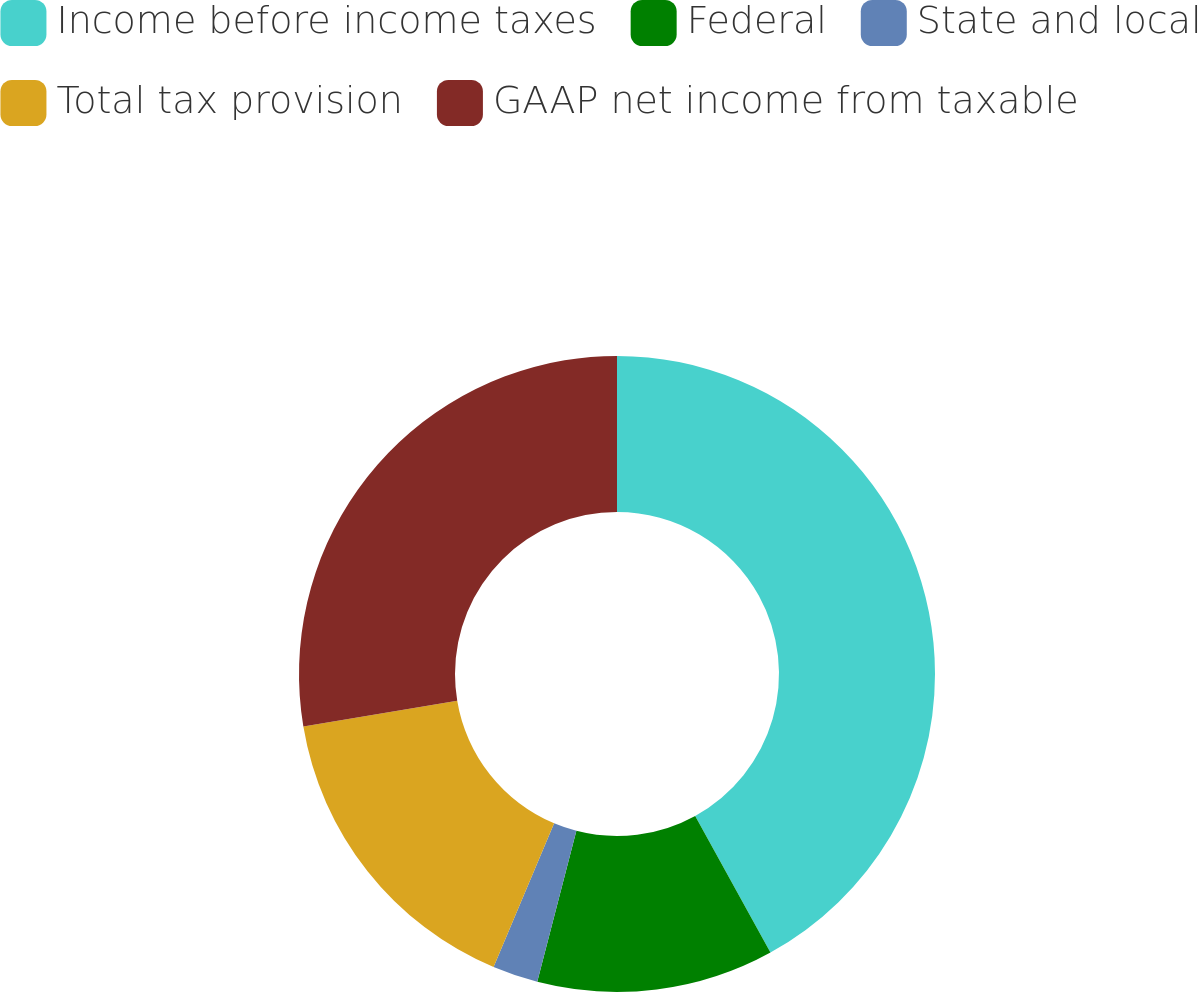Convert chart. <chart><loc_0><loc_0><loc_500><loc_500><pie_chart><fcel>Income before income taxes<fcel>Federal<fcel>State and local<fcel>Total tax provision<fcel>GAAP net income from taxable<nl><fcel>41.99%<fcel>12.05%<fcel>2.31%<fcel>16.02%<fcel>27.64%<nl></chart> 